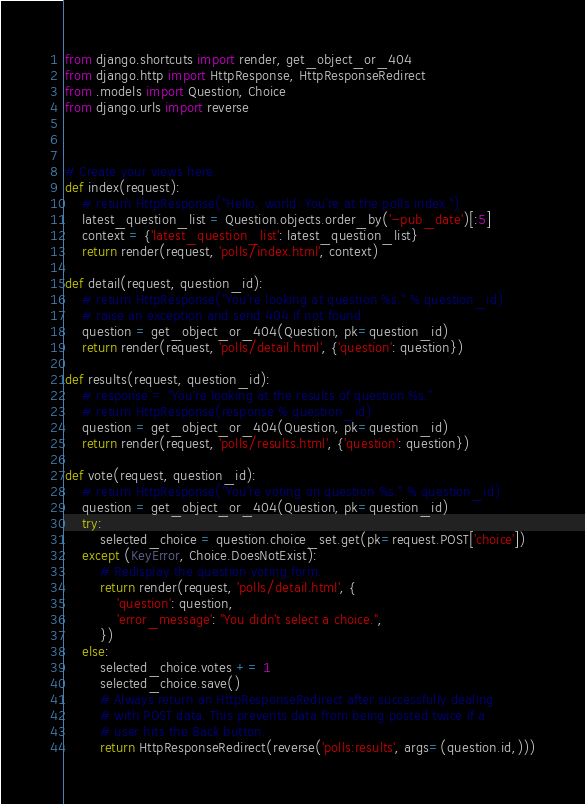<code> <loc_0><loc_0><loc_500><loc_500><_Python_>from django.shortcuts import render, get_object_or_404
from django.http import HttpResponse, HttpResponseRedirect
from .models import Question, Choice
from django.urls import reverse



# Create your views here.
def index(request):
    # return HttpResponse("Hello, world. You're at the polls index.")
    latest_question_list = Question.objects.order_by('-pub_date')[:5]
    context = {'latest_question_list': latest_question_list}
    return render(request, 'polls/index.html', context)

def detail(request, question_id):
    # return HttpResponse("You're looking at question %s." % question_id)
    # raise an exception and send 404 if not found
    question = get_object_or_404(Question, pk=question_id)
    return render(request, 'polls/detail.html', {'question': question})

def results(request, question_id):
    # response = "You're looking at the results of question %s."
    # return HttpResponse(response % question_id)
    question = get_object_or_404(Question, pk=question_id)
    return render(request, 'polls/results.html', {'question': question})

def vote(request, question_id):
    # return HttpResponse("You're voting on question %s." % question_id)
    question = get_object_or_404(Question, pk=question_id)
    try:
        selected_choice = question.choice_set.get(pk=request.POST['choice'])
    except (KeyError, Choice.DoesNotExist):
        # Redisplay the question voting form.
        return render(request, 'polls/detail.html', {
            'question': question,
            'error_message': "You didn't select a choice.",
        })
    else:
        selected_choice.votes += 1
        selected_choice.save()
        # Always return an HttpResponseRedirect after successfully dealing
        # with POST data. This prevents data from being posted twice if a
        # user hits the Back button.
        return HttpResponseRedirect(reverse('polls:results', args=(question.id,)))

</code> 